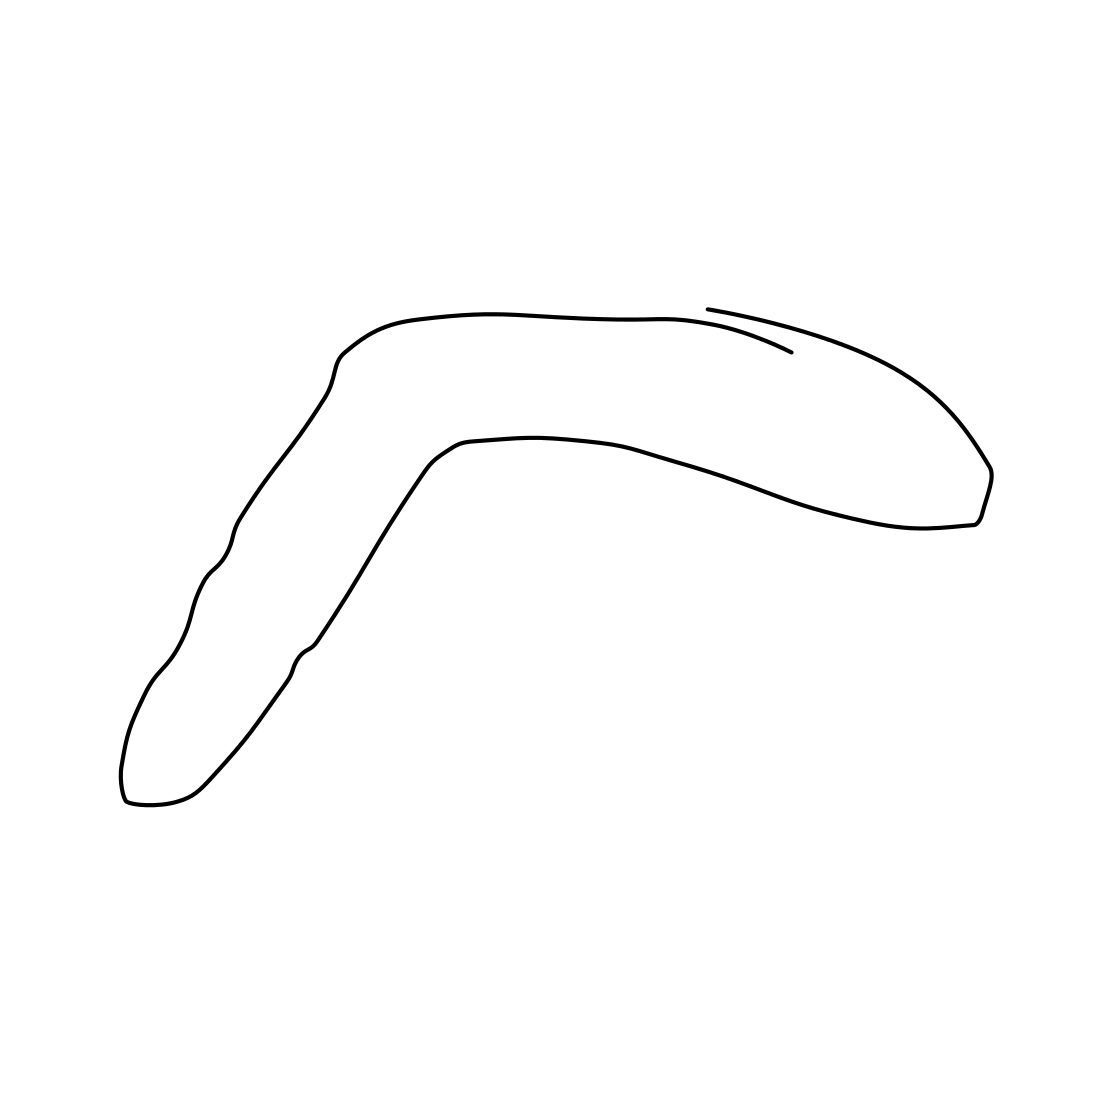Is there a sketchy mermaid in the picture? No 